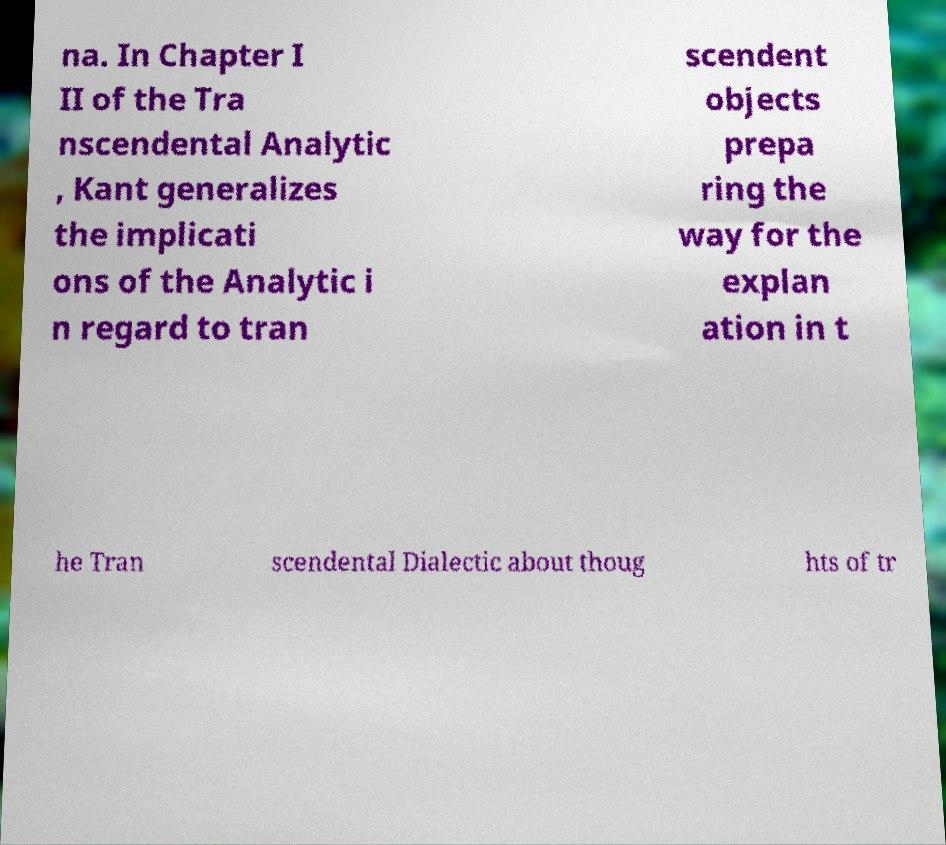Please read and relay the text visible in this image. What does it say? na. In Chapter I II of the Tra nscendental Analytic , Kant generalizes the implicati ons of the Analytic i n regard to tran scendent objects prepa ring the way for the explan ation in t he Tran scendental Dialectic about thoug hts of tr 